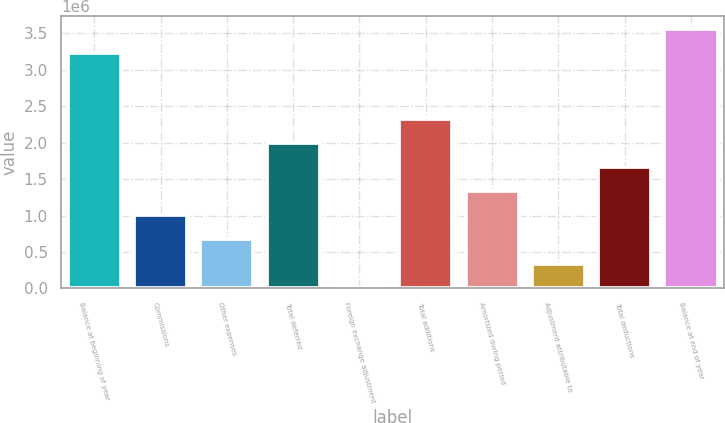Convert chart. <chart><loc_0><loc_0><loc_500><loc_500><bar_chart><fcel>Balance at beginning of year<fcel>Commissions<fcel>Other expenses<fcel>Total deferred<fcel>Foreign exchange adjustment<fcel>Total additions<fcel>Amortized during period<fcel>Adjustment attributable to<fcel>Total deductions<fcel>Balance at end of year<nl><fcel>3.22889e+06<fcel>1.00332e+06<fcel>672431<fcel>1.99597e+06<fcel>10663<fcel>2.32685e+06<fcel>1.3342e+06<fcel>341547<fcel>1.66508e+06<fcel>3.55977e+06<nl></chart> 